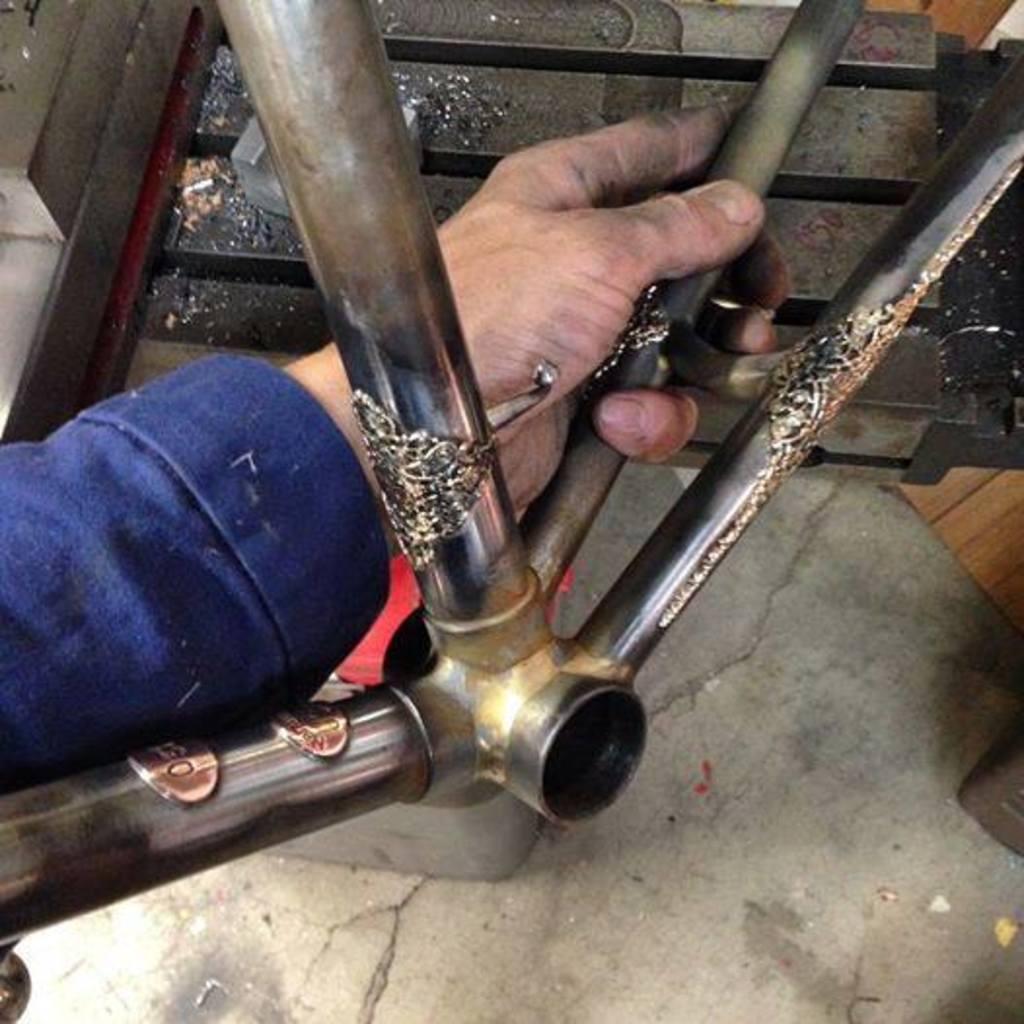Can you describe this image briefly? In this image I can see a person hand which is holding a road and the rod is kept on the floor. 